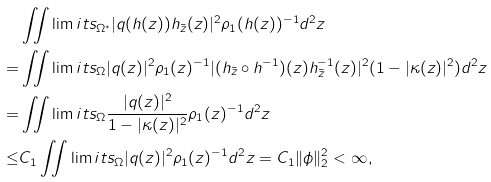<formula> <loc_0><loc_0><loc_500><loc_500>& \iint \lim i t s _ { \Omega ^ { * } } | q ( h ( z ) ) h _ { \bar { z } } ( z ) | ^ { 2 } \rho _ { 1 } ( h ( z ) ) ^ { - 1 } d ^ { 2 } z \\ = & \iint \lim i t s _ { \Omega } | q ( z ) | ^ { 2 } \rho _ { 1 } ( z ) ^ { - 1 } | ( h _ { \bar { z } } \circ h ^ { - 1 } ) ( z ) h _ { \bar { z } } ^ { - 1 } ( z ) | ^ { 2 } ( 1 - | \kappa ( z ) | ^ { 2 } ) d ^ { 2 } z \\ = & \iint \lim i t s _ { \Omega } \frac { | q ( z ) | ^ { 2 } } { 1 - | \kappa ( z ) | ^ { 2 } } \rho _ { 1 } ( z ) ^ { - 1 } d ^ { 2 } z \\ \leq & C _ { 1 } \iint \lim i t s _ { \Omega } | q ( z ) | ^ { 2 } \rho _ { 1 } ( z ) ^ { - 1 } d ^ { 2 } z = C _ { 1 } \| \phi \| ^ { 2 } _ { 2 } < \infty ,</formula> 